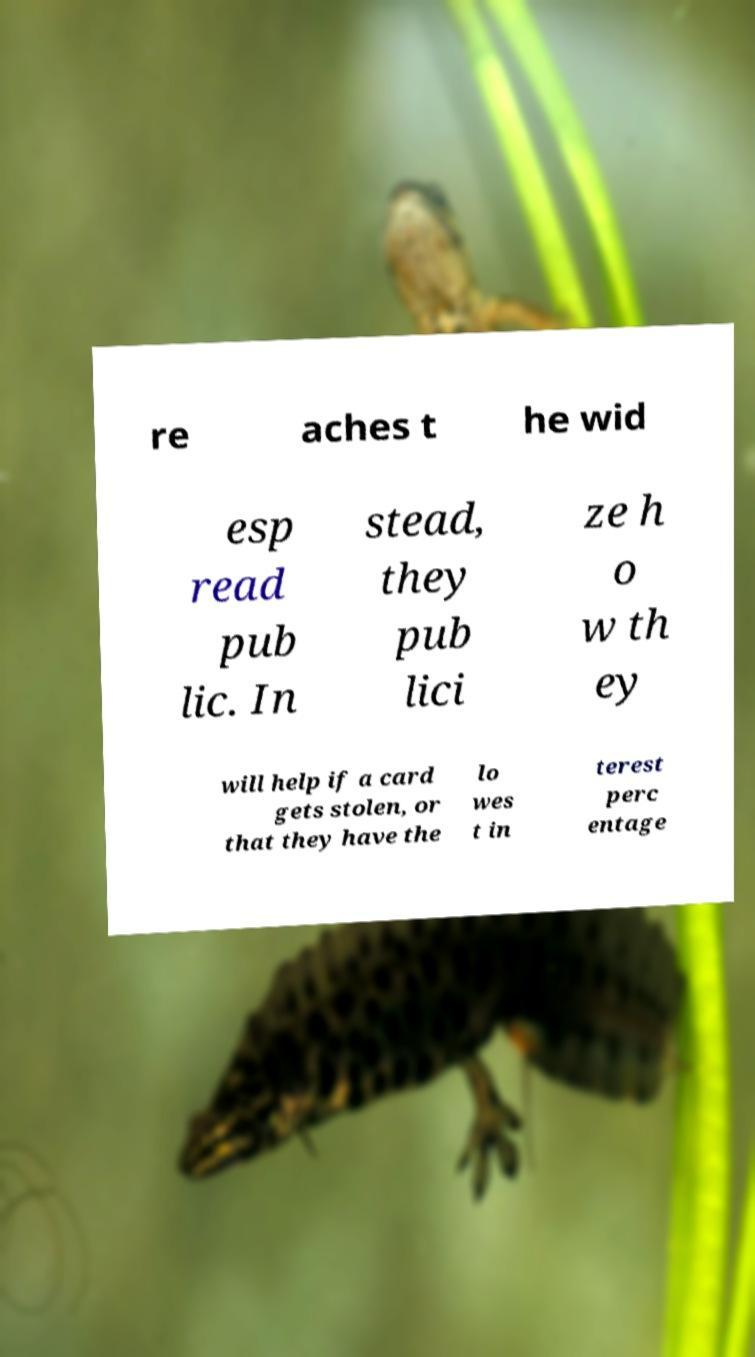Could you extract and type out the text from this image? re aches t he wid esp read pub lic. In stead, they pub lici ze h o w th ey will help if a card gets stolen, or that they have the lo wes t in terest perc entage 